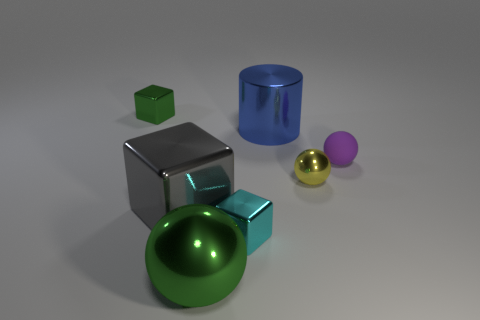What number of tiny metallic cubes are the same color as the big shiny sphere?
Your answer should be compact. 1. Are there more objects to the right of the large blue thing than large green things behind the purple matte object?
Make the answer very short. Yes. Is the material of the big ball right of the small green thing the same as the small purple sphere that is right of the large blue shiny object?
Provide a short and direct response. No. There is another yellow thing that is the same size as the matte object; what shape is it?
Keep it short and to the point. Sphere. Is there another tiny object of the same shape as the tiny yellow object?
Your answer should be very brief. Yes. There is a tiny object on the left side of the large ball; is it the same color as the small cube that is in front of the tiny purple ball?
Provide a succinct answer. No. There is a tiny purple rubber thing; are there any tiny objects to the left of it?
Your response must be concise. Yes. What is the object that is to the left of the tiny cyan block and in front of the gray thing made of?
Give a very brief answer. Metal. Do the green thing that is right of the gray cube and the tiny purple thing have the same material?
Keep it short and to the point. No. What is the material of the cyan cube?
Ensure brevity in your answer.  Metal. 